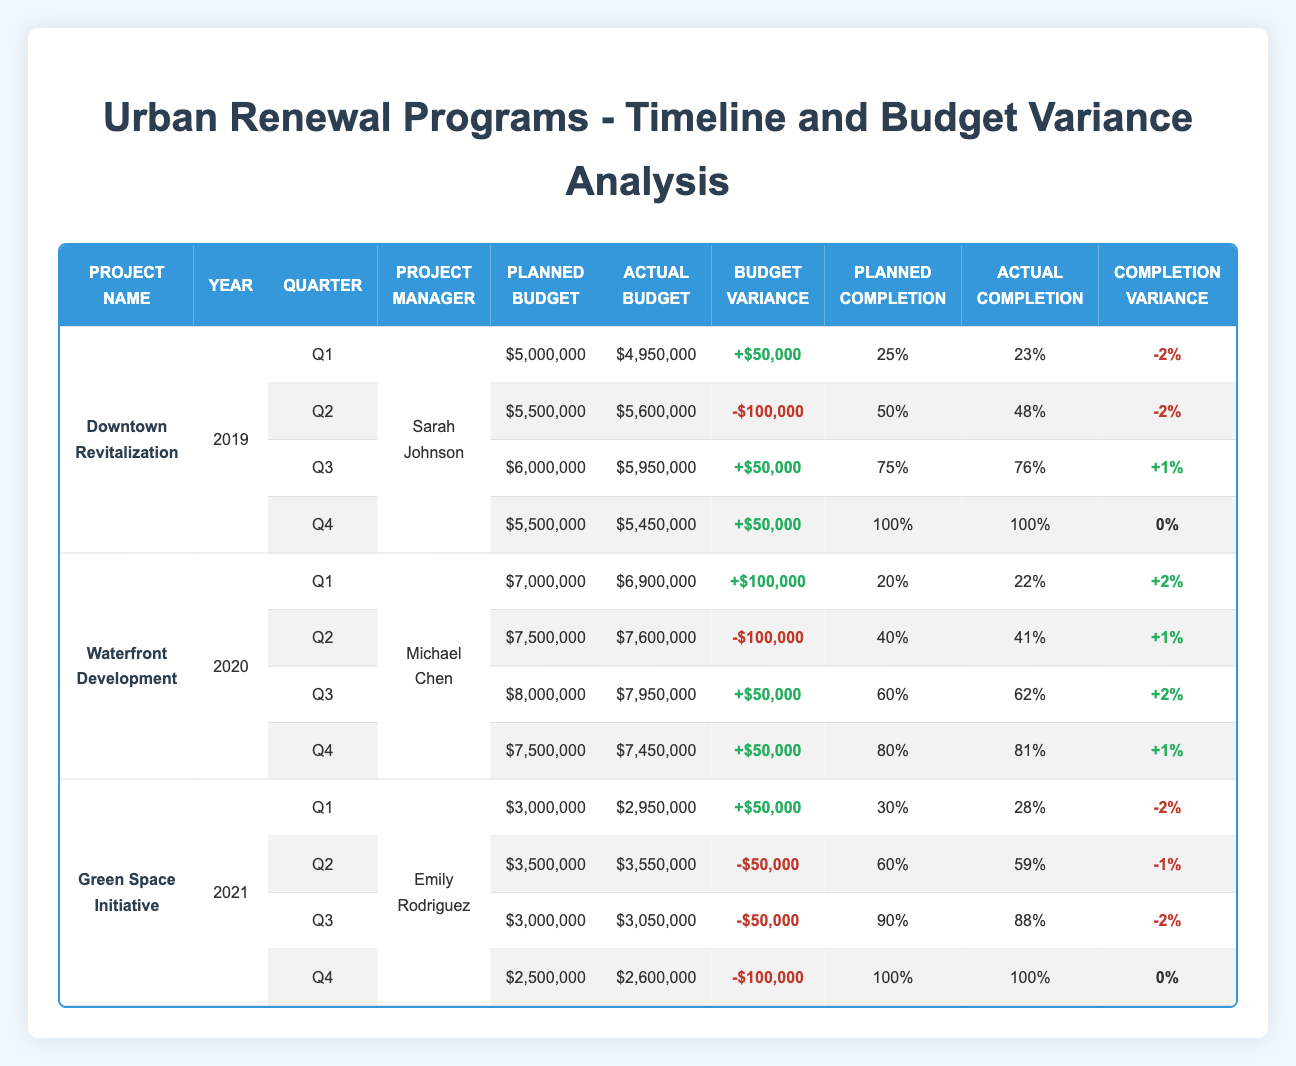What is the budget variance for the Downtown Revitalization project in Q2 2019? According to the table, the planned budget for Q2 is $5,500,000 and the actual budget is $5,600,000. The budget variance is calculated as actual budget minus planned budget: $5,600,000 - $5,500,000 = -$100,000. Thus, the budget variance for this project in Q2 is -$100,000.
Answer: -100,000 Which project had the highest actual budget in 2020? In the table, the actual budgets for the Waterfront Development project in 2020 are $6,900,000 in Q1, $7,600,000 in Q2, $7,950,000 in Q3, and $7,450,000 in Q4. Among these, $7,600,000 in Q2 is the highest actual budget for that year. Therefore, the project with the highest actual budget in 2020 is Waterfront Development in Q2.
Answer: Waterfront Development in Q2 Did the Green Space Initiative exceed its planned completion percentage in Q4 2021? The planned completion for Q4 2021 is 100%. The actual completion is also 100%. Therefore, since the actual completion does not exceed the planned completion, the answer is no. Thus, the Green Space Initiative did not exceed its planned completion percentage in Q4 2021.
Answer: No What is the average budget variance across all quarters for the Waterfront Development project in 2020? To find the average budget variance for the Waterfront Development project in 2020, we take the budget variances from each quarter: +$100,000 in Q1, -$100,000 in Q2, +$50,000 in Q3, and +$50,000 in Q4. The sum is $100,000 - $100,000 + $50,000 + $50,000 = $100,000. There are 4 quarters, so the average is $100,000 / 4 = $25,000. The average budget variance for the Waterfront Development project in 2020 is $25,000.
Answer: 25,000 Which project manager oversaw the Green Space Initiative and what was their budget variance for Q3 2021? The project manager for the Green Space Initiative is Emily Rodriguez. In Q3 2021, the planned budget is $3,000,000 and the actual budget is $3,050,000. The budget variance is calculated as actual budget minus planned budget: $3,050,000 - $3,000,000 = -$50,000. Thus, Emily Rodriguez oversaw the Green Space Initiative, and the budget variance for Q3 2021 was -$50,000.
Answer: Emily Rodriguez and -50,000 